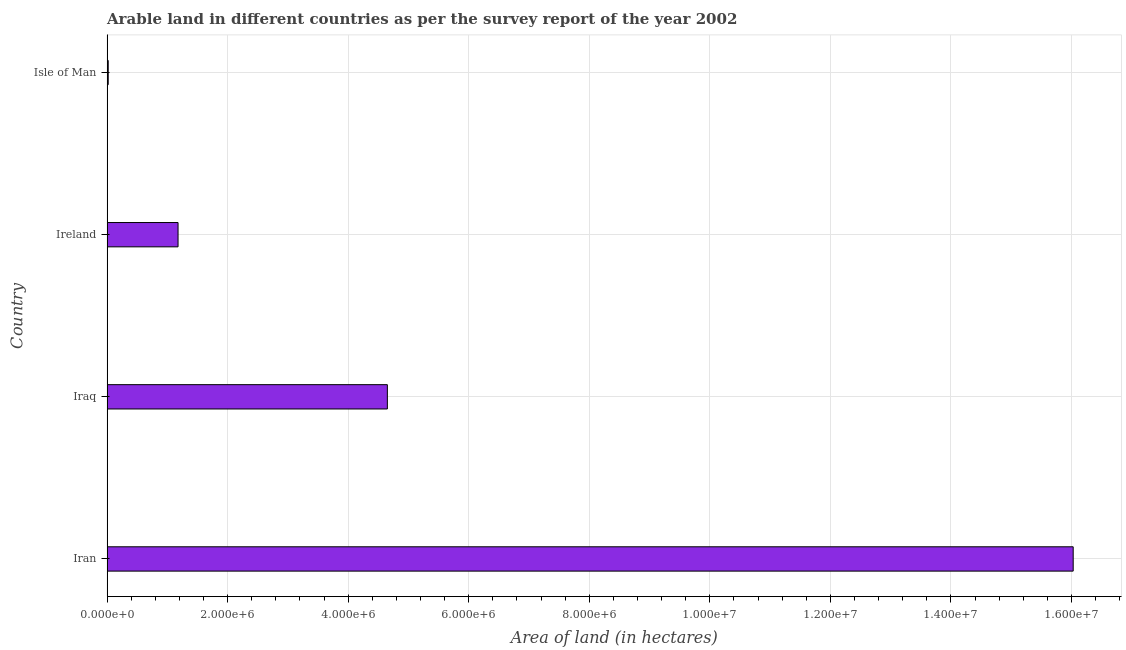Does the graph contain grids?
Give a very brief answer. Yes. What is the title of the graph?
Your response must be concise. Arable land in different countries as per the survey report of the year 2002. What is the label or title of the X-axis?
Your answer should be compact. Area of land (in hectares). What is the label or title of the Y-axis?
Your response must be concise. Country. What is the area of land in Ireland?
Offer a very short reply. 1.18e+06. Across all countries, what is the maximum area of land?
Offer a very short reply. 1.60e+07. Across all countries, what is the minimum area of land?
Your answer should be very brief. 1.85e+04. In which country was the area of land maximum?
Make the answer very short. Iran. In which country was the area of land minimum?
Keep it short and to the point. Isle of Man. What is the sum of the area of land?
Your answer should be compact. 2.19e+07. What is the difference between the area of land in Iran and Isle of Man?
Offer a very short reply. 1.60e+07. What is the average area of land per country?
Ensure brevity in your answer.  5.47e+06. What is the median area of land?
Offer a terse response. 2.91e+06. What is the ratio of the area of land in Iraq to that in Ireland?
Your answer should be very brief. 3.95. Is the area of land in Iran less than that in Iraq?
Provide a short and direct response. No. Is the difference between the area of land in Iraq and Isle of Man greater than the difference between any two countries?
Offer a terse response. No. What is the difference between the highest and the second highest area of land?
Your answer should be compact. 1.14e+07. Is the sum of the area of land in Ireland and Isle of Man greater than the maximum area of land across all countries?
Make the answer very short. No. What is the difference between the highest and the lowest area of land?
Provide a succinct answer. 1.60e+07. How many bars are there?
Offer a terse response. 4. How many countries are there in the graph?
Keep it short and to the point. 4. Are the values on the major ticks of X-axis written in scientific E-notation?
Keep it short and to the point. Yes. What is the Area of land (in hectares) in Iran?
Provide a short and direct response. 1.60e+07. What is the Area of land (in hectares) of Iraq?
Make the answer very short. 4.65e+06. What is the Area of land (in hectares) of Ireland?
Provide a succinct answer. 1.18e+06. What is the Area of land (in hectares) in Isle of Man?
Offer a very short reply. 1.85e+04. What is the difference between the Area of land (in hectares) in Iran and Iraq?
Offer a very short reply. 1.14e+07. What is the difference between the Area of land (in hectares) in Iran and Ireland?
Offer a terse response. 1.49e+07. What is the difference between the Area of land (in hectares) in Iran and Isle of Man?
Offer a terse response. 1.60e+07. What is the difference between the Area of land (in hectares) in Iraq and Ireland?
Ensure brevity in your answer.  3.47e+06. What is the difference between the Area of land (in hectares) in Iraq and Isle of Man?
Give a very brief answer. 4.63e+06. What is the difference between the Area of land (in hectares) in Ireland and Isle of Man?
Give a very brief answer. 1.16e+06. What is the ratio of the Area of land (in hectares) in Iran to that in Iraq?
Your response must be concise. 3.45. What is the ratio of the Area of land (in hectares) in Iran to that in Ireland?
Ensure brevity in your answer.  13.62. What is the ratio of the Area of land (in hectares) in Iran to that in Isle of Man?
Make the answer very short. 866.43. What is the ratio of the Area of land (in hectares) in Iraq to that in Ireland?
Your response must be concise. 3.95. What is the ratio of the Area of land (in hectares) in Iraq to that in Isle of Man?
Keep it short and to the point. 251.35. What is the ratio of the Area of land (in hectares) in Ireland to that in Isle of Man?
Your response must be concise. 63.62. 